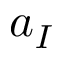<formula> <loc_0><loc_0><loc_500><loc_500>a _ { I }</formula> 